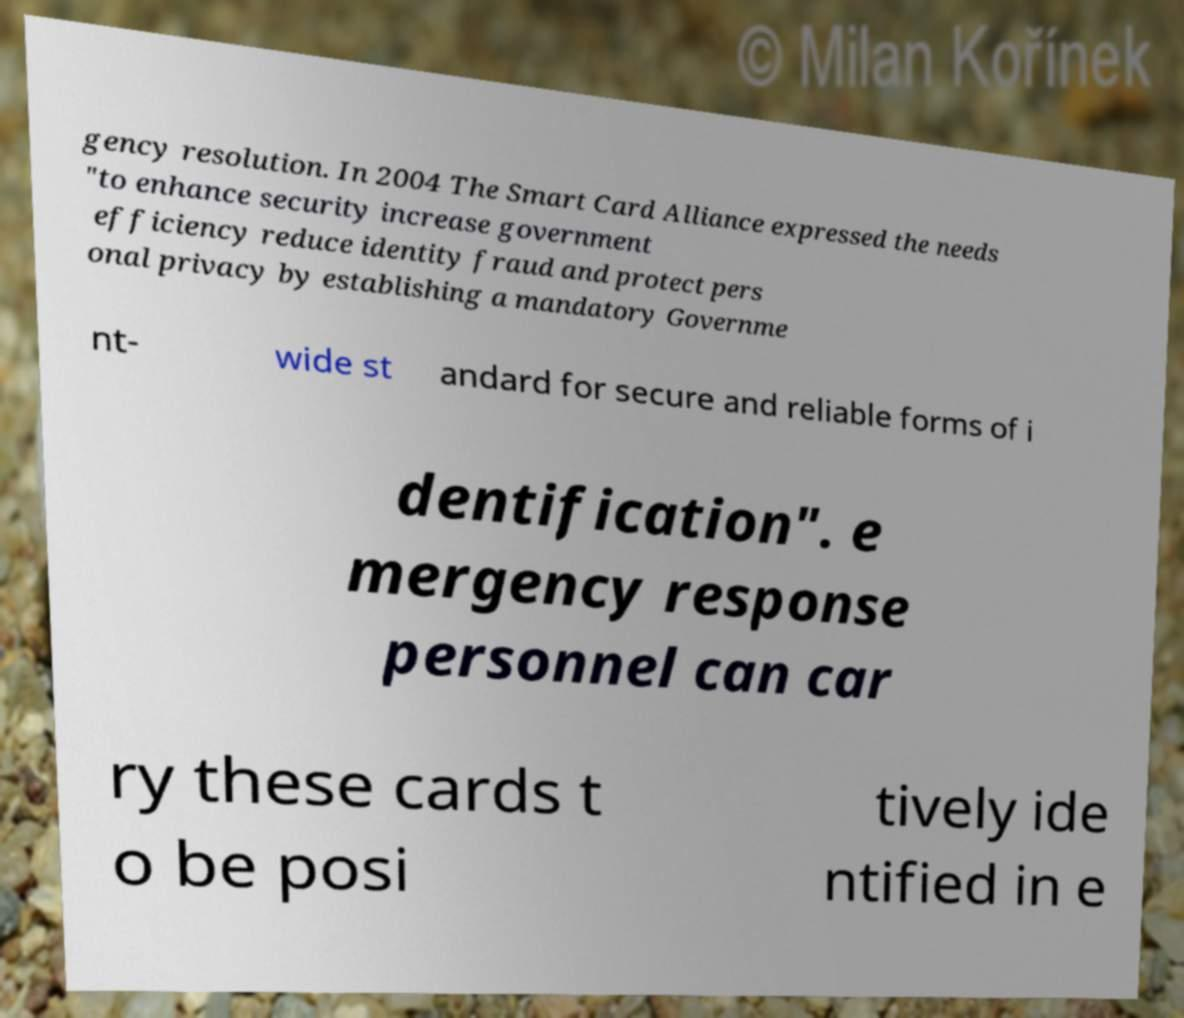I need the written content from this picture converted into text. Can you do that? gency resolution. In 2004 The Smart Card Alliance expressed the needs "to enhance security increase government efficiency reduce identity fraud and protect pers onal privacy by establishing a mandatory Governme nt- wide st andard for secure and reliable forms of i dentification". e mergency response personnel can car ry these cards t o be posi tively ide ntified in e 